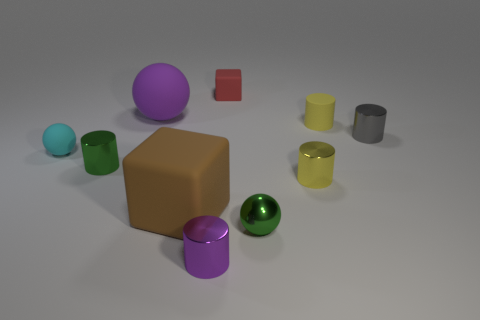What could be the context or setting for this group of objects? The setting looks like a neutral, artificial environment, possibly set up for a display or a study in geometry and color. It has an educational or demonstration purpose, suggesting an interest in the contrast and comparison between different shapes and colors. 